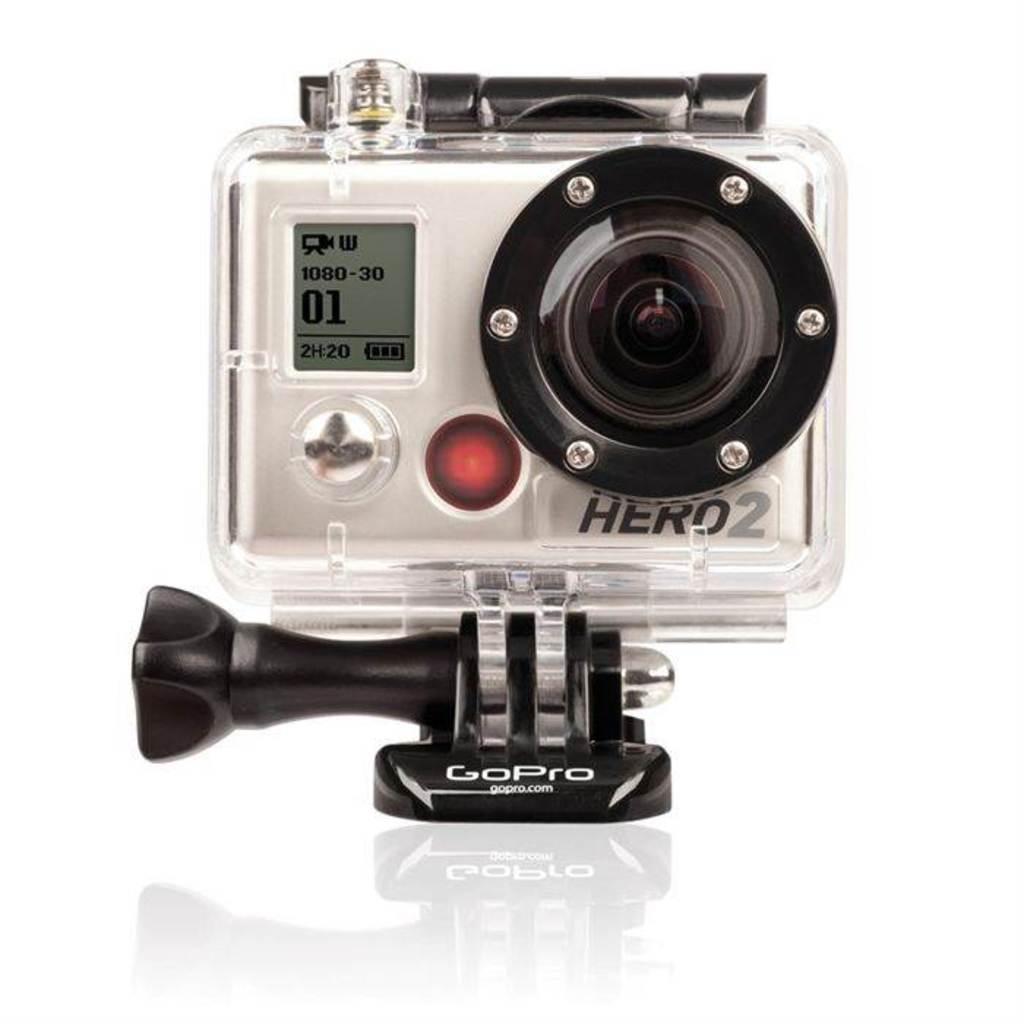How would you summarize this image in a sentence or two? There is a camera with screen and a lens. Also something is written on that. And it is on a white surface. In the background it is white. 